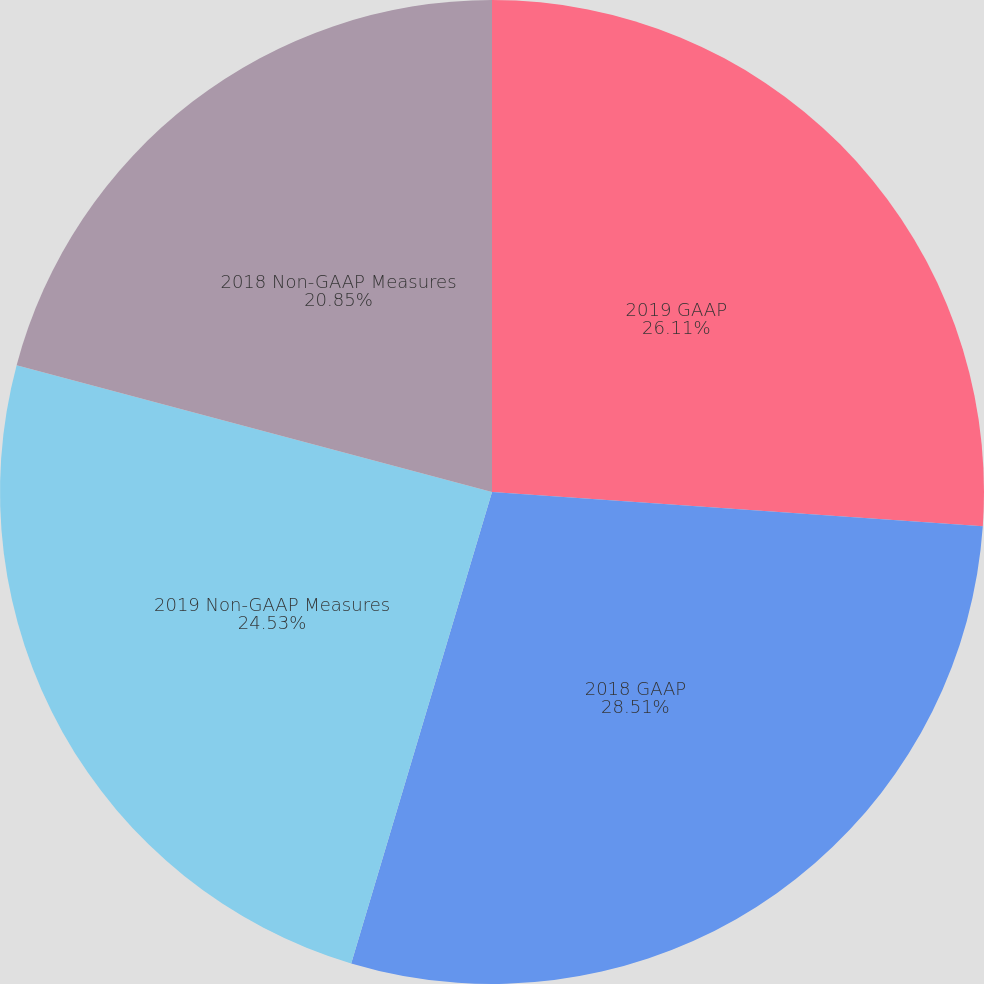<chart> <loc_0><loc_0><loc_500><loc_500><pie_chart><fcel>2019 GAAP<fcel>2018 GAAP<fcel>2019 Non-GAAP Measures<fcel>2018 Non-GAAP Measures<nl><fcel>26.11%<fcel>28.51%<fcel>24.53%<fcel>20.85%<nl></chart> 